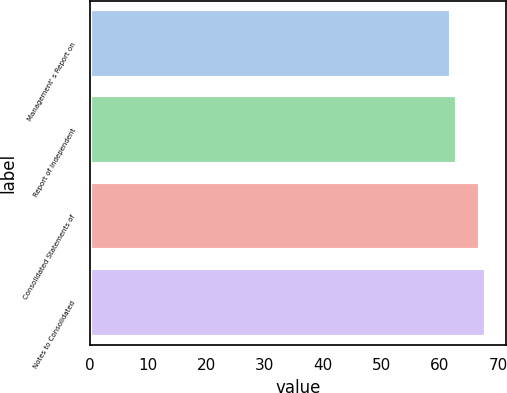<chart> <loc_0><loc_0><loc_500><loc_500><bar_chart><fcel>Management' s Report on<fcel>Report of Independent<fcel>Consolidated Statements of<fcel>Notes to Consolidated<nl><fcel>62<fcel>63<fcel>67<fcel>68<nl></chart> 